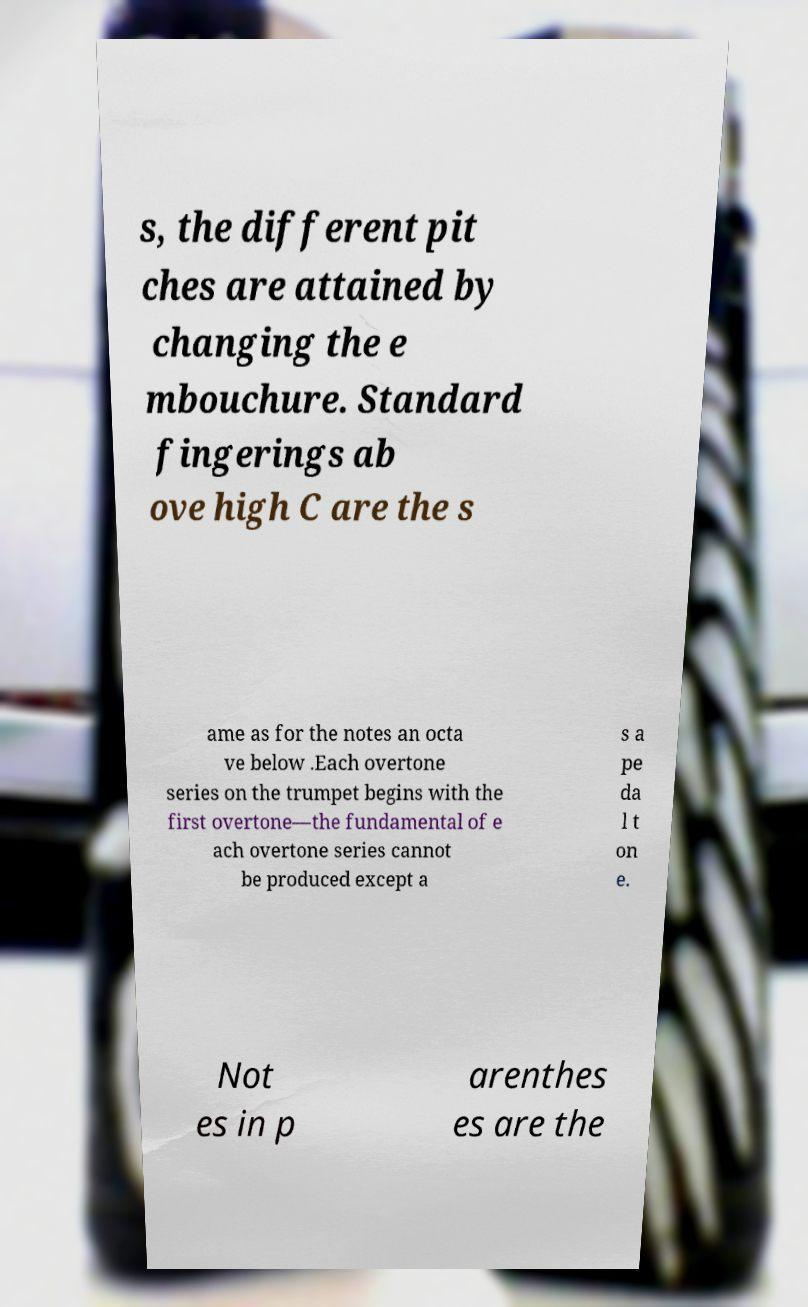Can you read and provide the text displayed in the image?This photo seems to have some interesting text. Can you extract and type it out for me? s, the different pit ches are attained by changing the e mbouchure. Standard fingerings ab ove high C are the s ame as for the notes an octa ve below .Each overtone series on the trumpet begins with the first overtone—the fundamental of e ach overtone series cannot be produced except a s a pe da l t on e. Not es in p arenthes es are the 